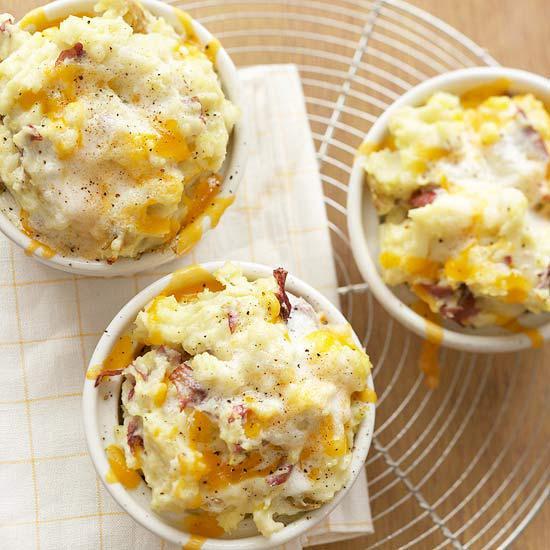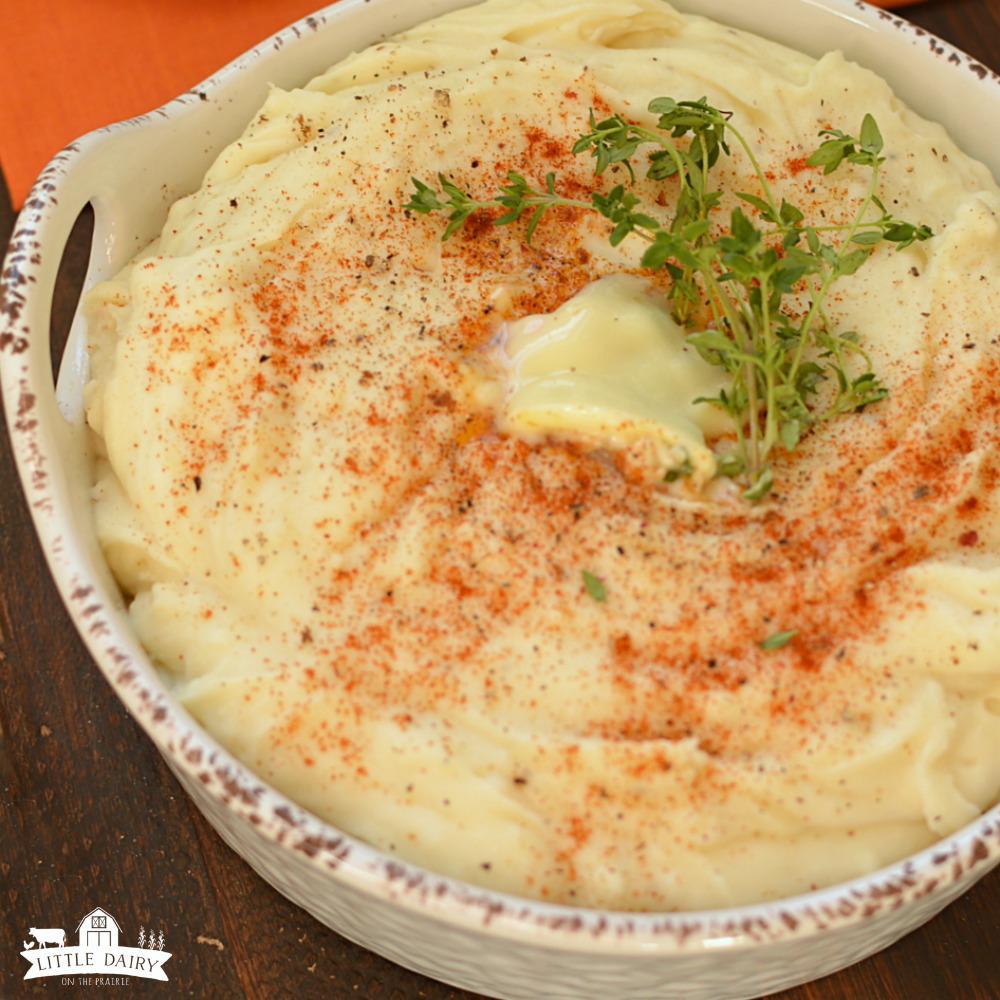The first image is the image on the left, the second image is the image on the right. Evaluate the accuracy of this statement regarding the images: "There is one bowl of potatoes with a sprig of greenery on it in at least one of the images.". Is it true? Answer yes or no. Yes. 